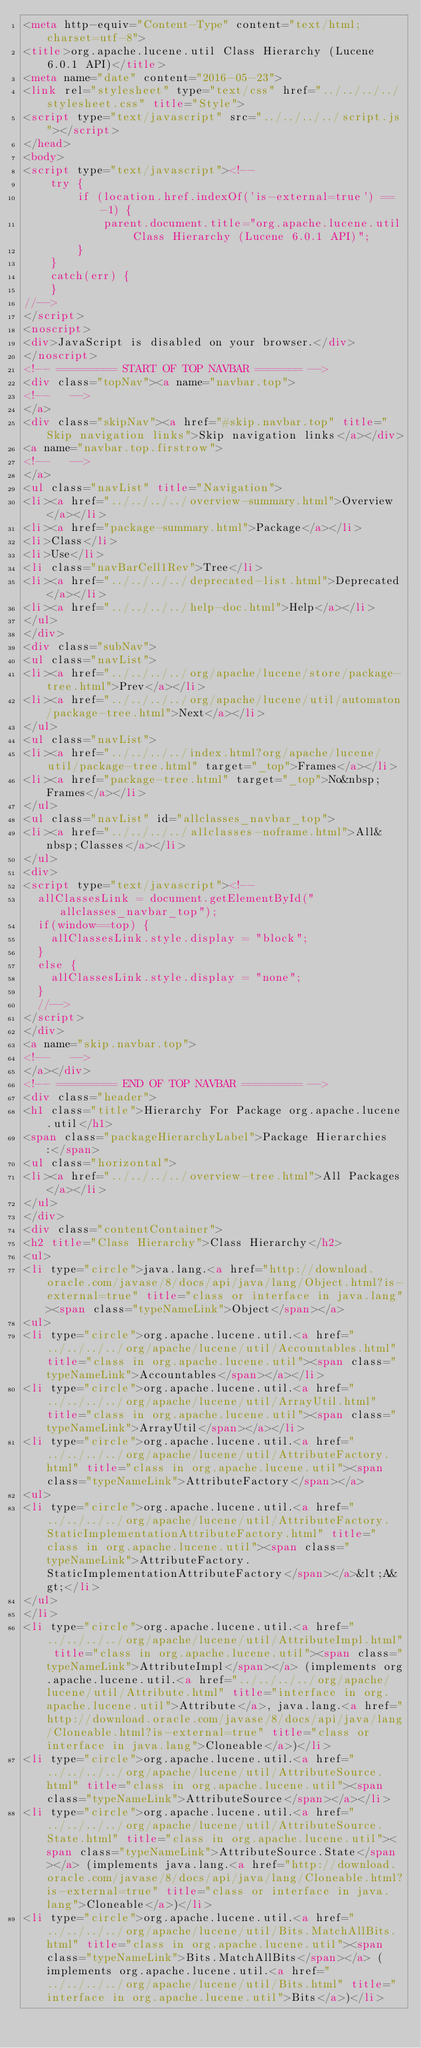<code> <loc_0><loc_0><loc_500><loc_500><_HTML_><meta http-equiv="Content-Type" content="text/html; charset=utf-8">
<title>org.apache.lucene.util Class Hierarchy (Lucene 6.0.1 API)</title>
<meta name="date" content="2016-05-23">
<link rel="stylesheet" type="text/css" href="../../../../stylesheet.css" title="Style">
<script type="text/javascript" src="../../../../script.js"></script>
</head>
<body>
<script type="text/javascript"><!--
    try {
        if (location.href.indexOf('is-external=true') == -1) {
            parent.document.title="org.apache.lucene.util Class Hierarchy (Lucene 6.0.1 API)";
        }
    }
    catch(err) {
    }
//-->
</script>
<noscript>
<div>JavaScript is disabled on your browser.</div>
</noscript>
<!-- ========= START OF TOP NAVBAR ======= -->
<div class="topNav"><a name="navbar.top">
<!--   -->
</a>
<div class="skipNav"><a href="#skip.navbar.top" title="Skip navigation links">Skip navigation links</a></div>
<a name="navbar.top.firstrow">
<!--   -->
</a>
<ul class="navList" title="Navigation">
<li><a href="../../../../overview-summary.html">Overview</a></li>
<li><a href="package-summary.html">Package</a></li>
<li>Class</li>
<li>Use</li>
<li class="navBarCell1Rev">Tree</li>
<li><a href="../../../../deprecated-list.html">Deprecated</a></li>
<li><a href="../../../../help-doc.html">Help</a></li>
</ul>
</div>
<div class="subNav">
<ul class="navList">
<li><a href="../../../../org/apache/lucene/store/package-tree.html">Prev</a></li>
<li><a href="../../../../org/apache/lucene/util/automaton/package-tree.html">Next</a></li>
</ul>
<ul class="navList">
<li><a href="../../../../index.html?org/apache/lucene/util/package-tree.html" target="_top">Frames</a></li>
<li><a href="package-tree.html" target="_top">No&nbsp;Frames</a></li>
</ul>
<ul class="navList" id="allclasses_navbar_top">
<li><a href="../../../../allclasses-noframe.html">All&nbsp;Classes</a></li>
</ul>
<div>
<script type="text/javascript"><!--
  allClassesLink = document.getElementById("allclasses_navbar_top");
  if(window==top) {
    allClassesLink.style.display = "block";
  }
  else {
    allClassesLink.style.display = "none";
  }
  //-->
</script>
</div>
<a name="skip.navbar.top">
<!--   -->
</a></div>
<!-- ========= END OF TOP NAVBAR ========= -->
<div class="header">
<h1 class="title">Hierarchy For Package org.apache.lucene.util</h1>
<span class="packageHierarchyLabel">Package Hierarchies:</span>
<ul class="horizontal">
<li><a href="../../../../overview-tree.html">All Packages</a></li>
</ul>
</div>
<div class="contentContainer">
<h2 title="Class Hierarchy">Class Hierarchy</h2>
<ul>
<li type="circle">java.lang.<a href="http://download.oracle.com/javase/8/docs/api/java/lang/Object.html?is-external=true" title="class or interface in java.lang"><span class="typeNameLink">Object</span></a>
<ul>
<li type="circle">org.apache.lucene.util.<a href="../../../../org/apache/lucene/util/Accountables.html" title="class in org.apache.lucene.util"><span class="typeNameLink">Accountables</span></a></li>
<li type="circle">org.apache.lucene.util.<a href="../../../../org/apache/lucene/util/ArrayUtil.html" title="class in org.apache.lucene.util"><span class="typeNameLink">ArrayUtil</span></a></li>
<li type="circle">org.apache.lucene.util.<a href="../../../../org/apache/lucene/util/AttributeFactory.html" title="class in org.apache.lucene.util"><span class="typeNameLink">AttributeFactory</span></a>
<ul>
<li type="circle">org.apache.lucene.util.<a href="../../../../org/apache/lucene/util/AttributeFactory.StaticImplementationAttributeFactory.html" title="class in org.apache.lucene.util"><span class="typeNameLink">AttributeFactory.StaticImplementationAttributeFactory</span></a>&lt;A&gt;</li>
</ul>
</li>
<li type="circle">org.apache.lucene.util.<a href="../../../../org/apache/lucene/util/AttributeImpl.html" title="class in org.apache.lucene.util"><span class="typeNameLink">AttributeImpl</span></a> (implements org.apache.lucene.util.<a href="../../../../org/apache/lucene/util/Attribute.html" title="interface in org.apache.lucene.util">Attribute</a>, java.lang.<a href="http://download.oracle.com/javase/8/docs/api/java/lang/Cloneable.html?is-external=true" title="class or interface in java.lang">Cloneable</a>)</li>
<li type="circle">org.apache.lucene.util.<a href="../../../../org/apache/lucene/util/AttributeSource.html" title="class in org.apache.lucene.util"><span class="typeNameLink">AttributeSource</span></a></li>
<li type="circle">org.apache.lucene.util.<a href="../../../../org/apache/lucene/util/AttributeSource.State.html" title="class in org.apache.lucene.util"><span class="typeNameLink">AttributeSource.State</span></a> (implements java.lang.<a href="http://download.oracle.com/javase/8/docs/api/java/lang/Cloneable.html?is-external=true" title="class or interface in java.lang">Cloneable</a>)</li>
<li type="circle">org.apache.lucene.util.<a href="../../../../org/apache/lucene/util/Bits.MatchAllBits.html" title="class in org.apache.lucene.util"><span class="typeNameLink">Bits.MatchAllBits</span></a> (implements org.apache.lucene.util.<a href="../../../../org/apache/lucene/util/Bits.html" title="interface in org.apache.lucene.util">Bits</a>)</li></code> 